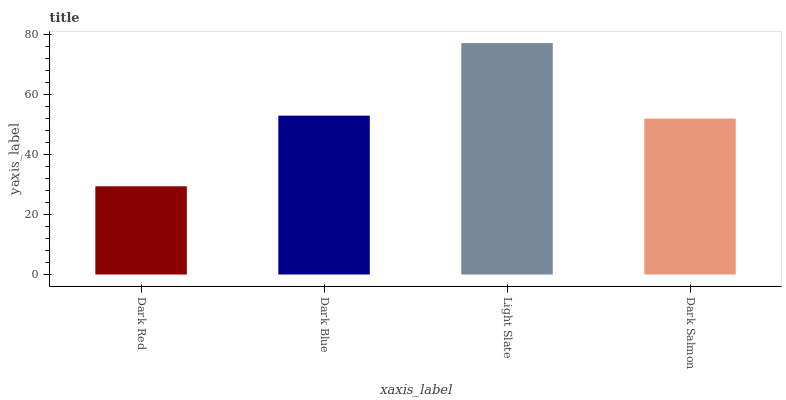Is Dark Red the minimum?
Answer yes or no. Yes. Is Light Slate the maximum?
Answer yes or no. Yes. Is Dark Blue the minimum?
Answer yes or no. No. Is Dark Blue the maximum?
Answer yes or no. No. Is Dark Blue greater than Dark Red?
Answer yes or no. Yes. Is Dark Red less than Dark Blue?
Answer yes or no. Yes. Is Dark Red greater than Dark Blue?
Answer yes or no. No. Is Dark Blue less than Dark Red?
Answer yes or no. No. Is Dark Blue the high median?
Answer yes or no. Yes. Is Dark Salmon the low median?
Answer yes or no. Yes. Is Dark Red the high median?
Answer yes or no. No. Is Dark Red the low median?
Answer yes or no. No. 